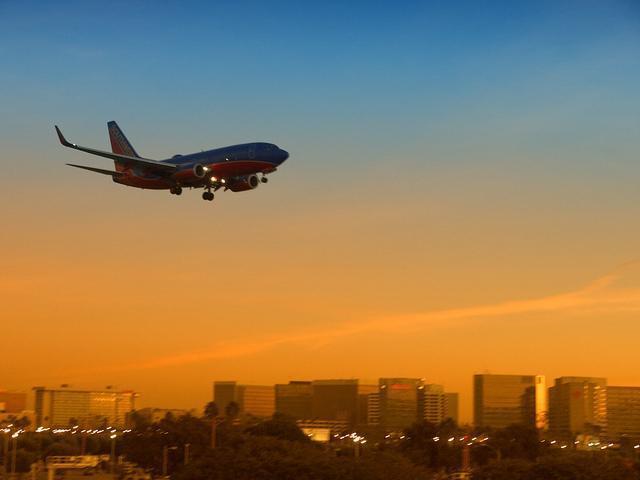How many airplanes can be seen?
Give a very brief answer. 1. 